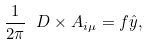Convert formula to latex. <formula><loc_0><loc_0><loc_500><loc_500>\frac { 1 } { 2 \pi } \ D \times A _ { i \mu } = f \hat { y } ,</formula> 